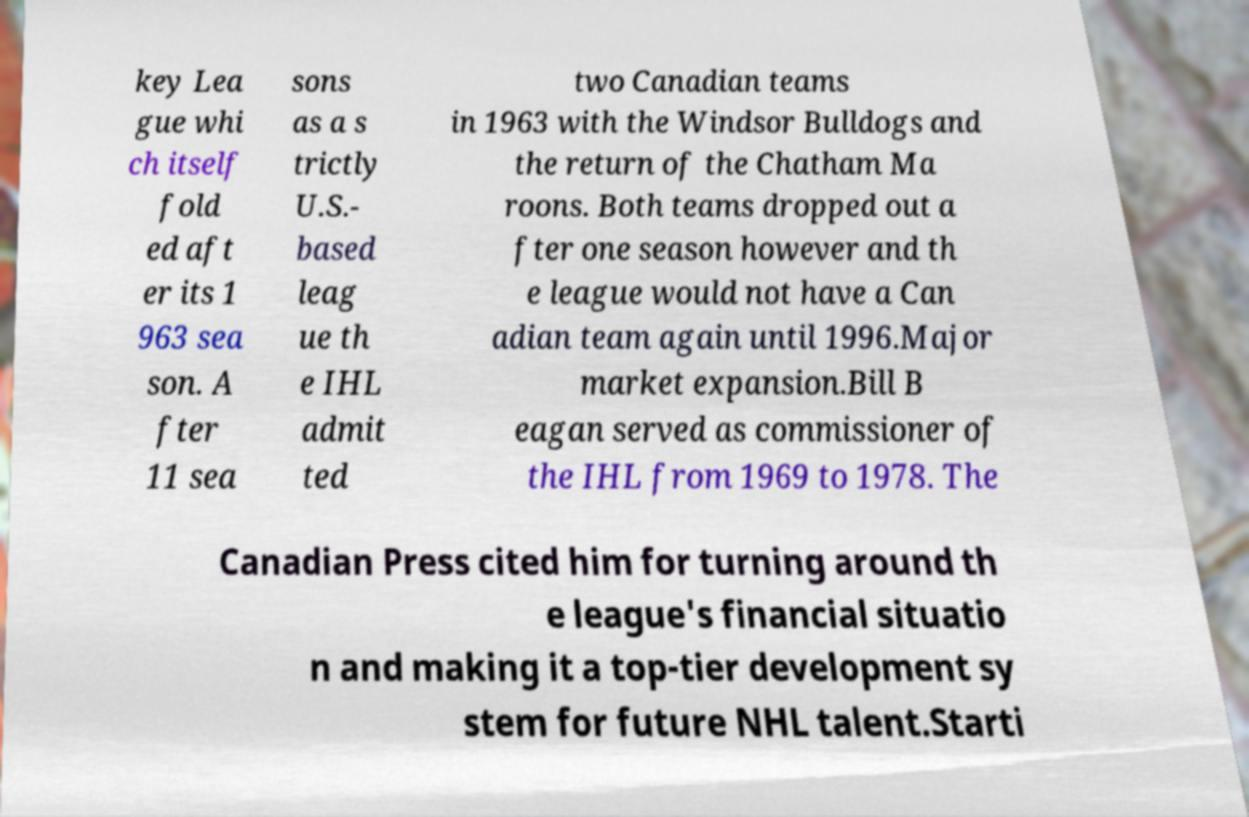Could you assist in decoding the text presented in this image and type it out clearly? key Lea gue whi ch itself fold ed aft er its 1 963 sea son. A fter 11 sea sons as a s trictly U.S.- based leag ue th e IHL admit ted two Canadian teams in 1963 with the Windsor Bulldogs and the return of the Chatham Ma roons. Both teams dropped out a fter one season however and th e league would not have a Can adian team again until 1996.Major market expansion.Bill B eagan served as commissioner of the IHL from 1969 to 1978. The Canadian Press cited him for turning around th e league's financial situatio n and making it a top-tier development sy stem for future NHL talent.Starti 